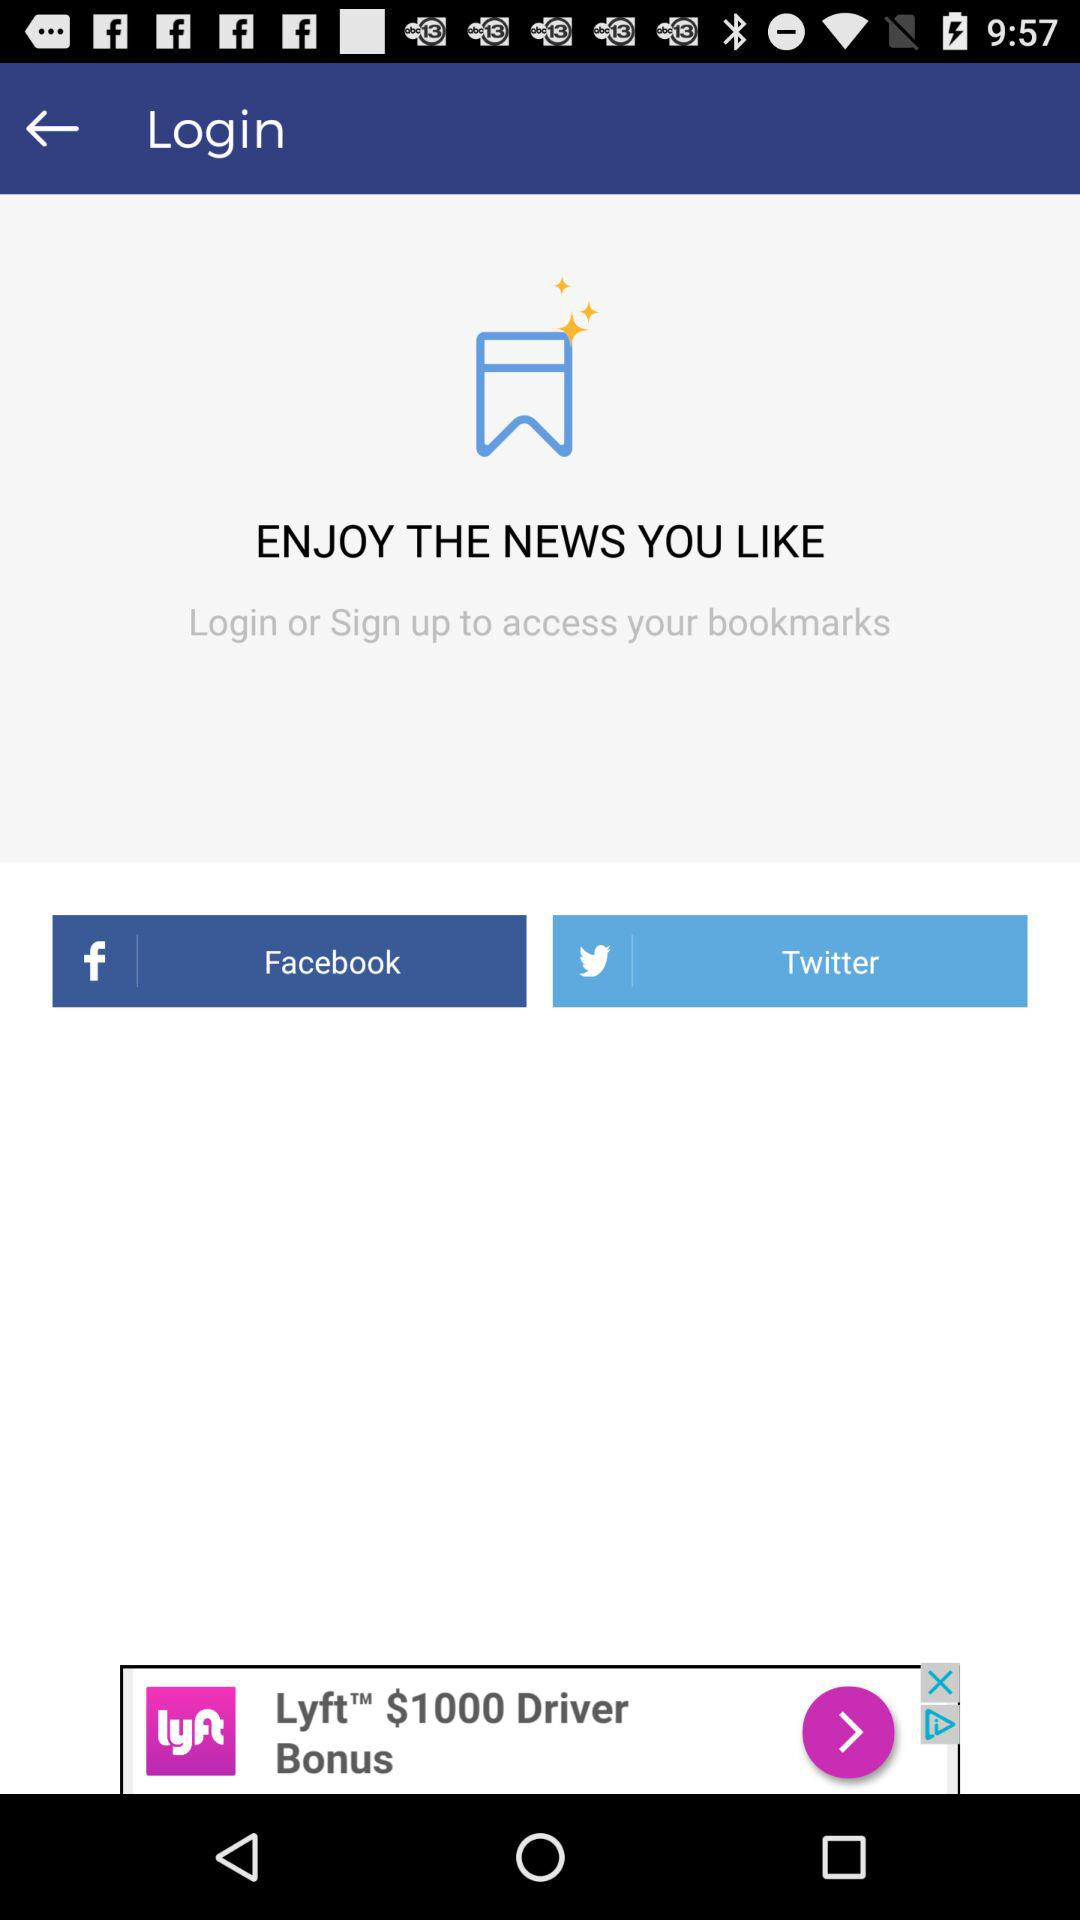Which applications can be used to sign up? The applications that can be used to sign up are "Facebook" and "Twitter". 